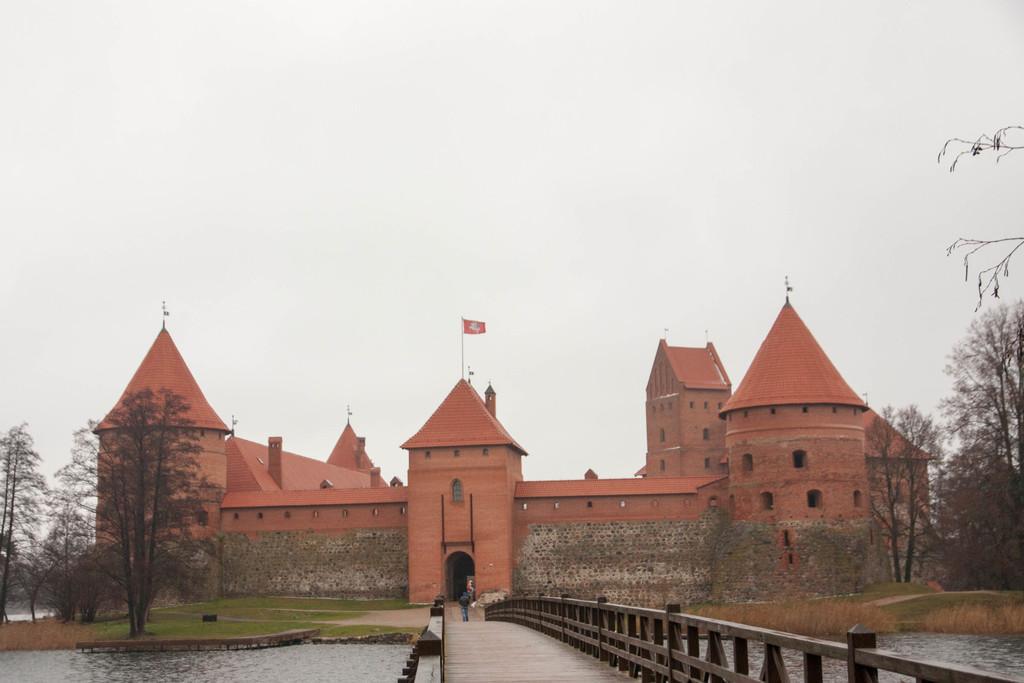How would you summarize this image in a sentence or two? In this image in the front there is a bridge and under the bridge there is water. In the background there is grass on the ground, there are trees and there is a fort and on the top of the fort there are flags. 